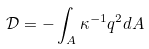Convert formula to latex. <formula><loc_0><loc_0><loc_500><loc_500>\mathcal { D } = - \int _ { A } \kappa ^ { - 1 } q ^ { 2 } d A</formula> 